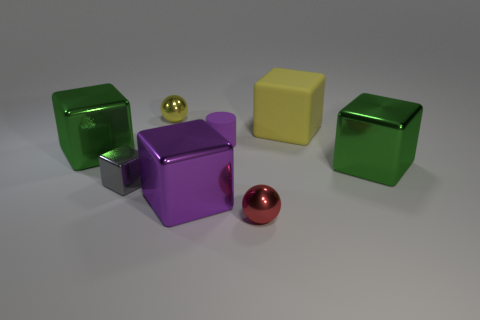Subtract all yellow blocks. How many blocks are left? 4 Subtract all small metal blocks. How many blocks are left? 4 Subtract all blue cubes. Subtract all green balls. How many cubes are left? 5 Add 1 big green cubes. How many objects exist? 9 Subtract all blocks. How many objects are left? 3 Subtract all tiny red things. Subtract all tiny cyan shiny spheres. How many objects are left? 7 Add 4 blocks. How many blocks are left? 9 Add 4 big gray shiny cubes. How many big gray shiny cubes exist? 4 Subtract 0 green balls. How many objects are left? 8 